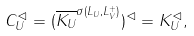Convert formula to latex. <formula><loc_0><loc_0><loc_500><loc_500>C _ { U } ^ { \lhd } = ( \overline { K _ { U } } ^ { \sigma ( L _ { U } , L _ { V } ^ { + } ) } ) ^ { \lhd } = K _ { U } ^ { \lhd } ,</formula> 